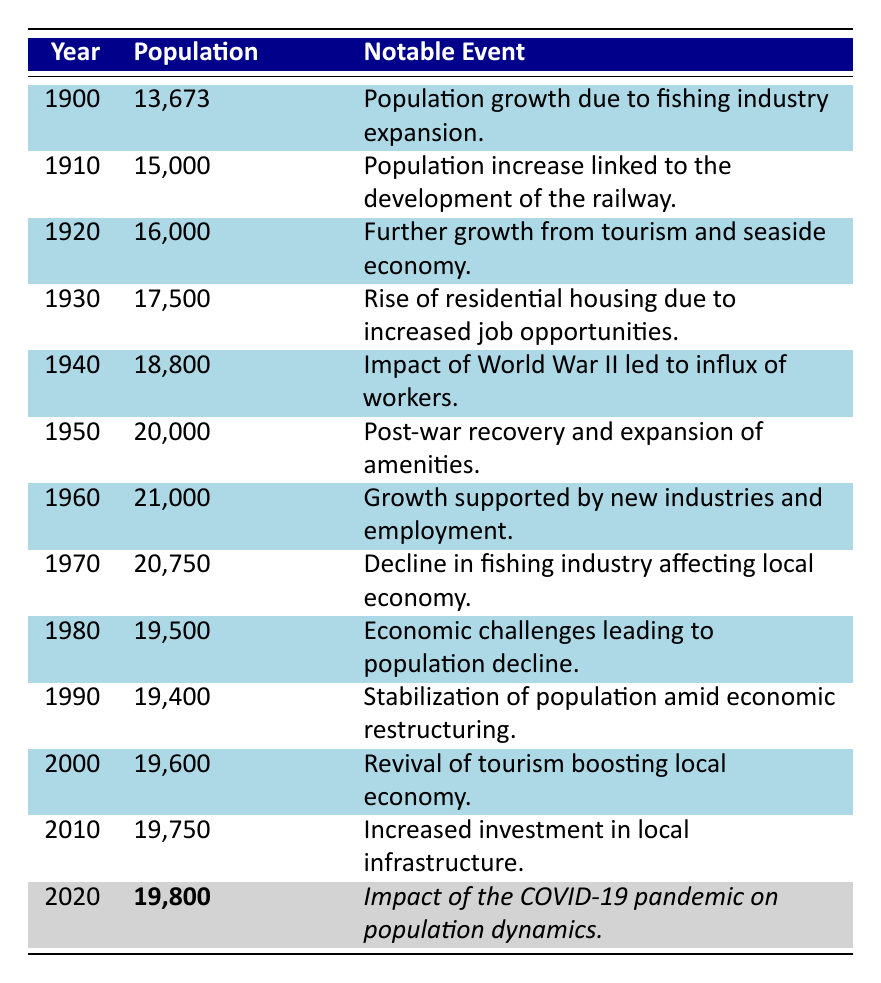What was the population of Lowestoft in 1950? The table shows that the population in 1950 is listed as 20,000.
Answer: 20,000 Which year saw the highest population growth compared to the previous decade? To find the highest population growth, compare populations from decade to decade. Between 1940 (18,800) and 1950 (20,000), there was an increase of 1,200, which is the largest among the corresponding periods.
Answer: 1950 Was the population in 1980 higher or lower than in 1990? The population in 1980 is 19,500, while in 1990 it is 19,400. Since 19,500 is greater than 19,400, it indicates that the population in 1980 was higher.
Answer: Higher What was the change in population from 2000 to 2010? The population in 2000 is 19,600 and in 2010 it is 19,750. The change can be calculated as 19,750 - 19,600 = 150.
Answer: 150 What was the average population from 1900 to 2020? The populations from 1900 to 2020 are: 13,673, 15,000, 16,000, 17,500, 18,800, 20,000, 21,000, 20,750, 19,500, 19,400, 19,600, 19,750, and 19,800. The sum is 13,673 + 15,000 + 16,000 + 17,500 + 18,800 + 20,000 + 21,000 + 20750 + 19,500 + 19,400 + 19,600 + 19,750 + 19,800 = 250,173. There are 13 years, so the average is 250,173 / 13 = 19,218.23077, which rounds to 19,218.
Answer: 19,218 Between which years did the population see a significant decline? A significant decline occurs between 1970 (20,750) and 1980 (19,500), where the population decreased by 1,250.
Answer: 1970 to 1980 Did the population ever drop to below 20,000 from 1970 onwards? From 1970 onwards, populations recorded are: 20,750 (1970), 19,500 (1980), 19,400 (1990), 19,600 (2000), 19,750 (2010), and 19,800 (2020). It shows that the population dropped below 20,000 in 1980 and did not exceed it until 2000. Thus, the answer is yes.
Answer: Yes What notable event corresponds with the population in 1940? The table indicates that the notable event corresponding with the year 1940 is the influx of workers due to the impact of World War II.
Answer: Influx of workers due to World War II How many years had a population of over 20,000? The years with populations over 20,000 are 1950 (20,000, counted), 1960 (21,000). This totals two years with populations over 20,000.
Answer: 2 What was the overall trend in population from 1900 to 2020? Analyzing the table, the population increased markedly until around 1970, then experienced declines in 1980 and subsequent years, stabilizing and gradually increasing until 2020.
Answer: Increasing until 1970, then declining, stabilizing, and increasing slightly until 2020 Which decade experienced the least population change? The least population change can be observed from 1990 (19,400) to 2000 (19,600). The change was only a 200 increase, the smallest across all decades.
Answer: 1990 to 2000 